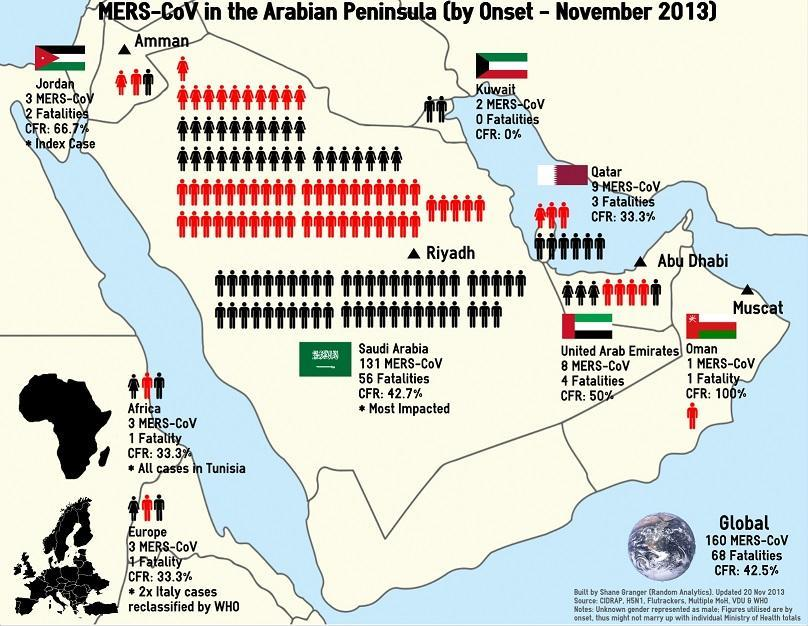How many people were affected by the MERS virus in Kuwait as of November 2013 since the onset?
Answer the question with a short phrase. 2 What is the case fatality rate of MERS-CoV in Jordan as of November 2013 since the onset? 66.7% How many people were affected by the MERS virus globally as of  November 2013 since the onset? 160 Which country in the Arabian Peninsula didn't report any fatalities due to the MERS virus as of November 2013 since the onset? Kuwait How many deaths were caused by the MERS-CoV in UAE as of November 2013 since the onset? 4 How many people were affected by the MERS virus in Europe as of November 2013 since the onset? 3 What is the case fatality rate of MERS-CoV in Africa as of November 2013 since the onset? 33.3% Which country in the Arabian Peninsula has reported the highest number of fatalities due to the MERS virus as of November 2013 since the onset? Saudi Arabia Which country in the Arabian Peninsula has reported 100 percent CFR due to the MERS virus as of November 2013 since the onset? Oman Which country in the Arabian Peninsula is most affected by the MERS virus as of November 2013 since the onset? Saudi Arabia 